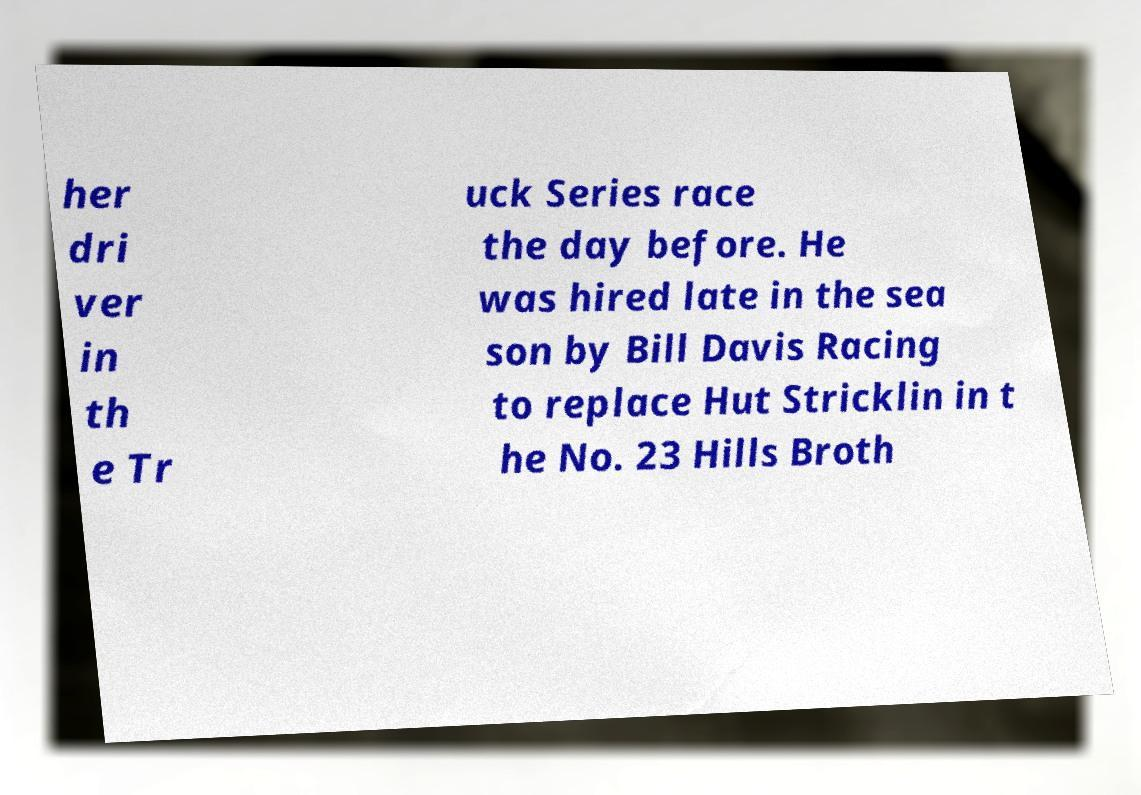For documentation purposes, I need the text within this image transcribed. Could you provide that? her dri ver in th e Tr uck Series race the day before. He was hired late in the sea son by Bill Davis Racing to replace Hut Stricklin in t he No. 23 Hills Broth 